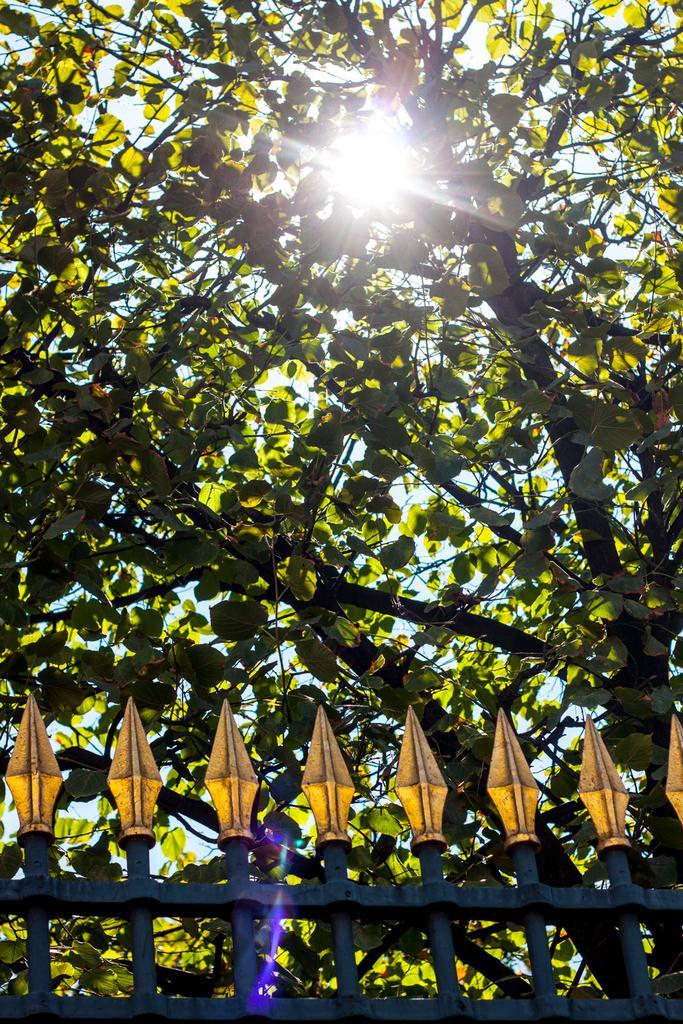Describe this image in one or two sentences. At the bottom of the image I can see the railing. At the top of it I can see a tree. At the top of the image I can see the sunlight. 